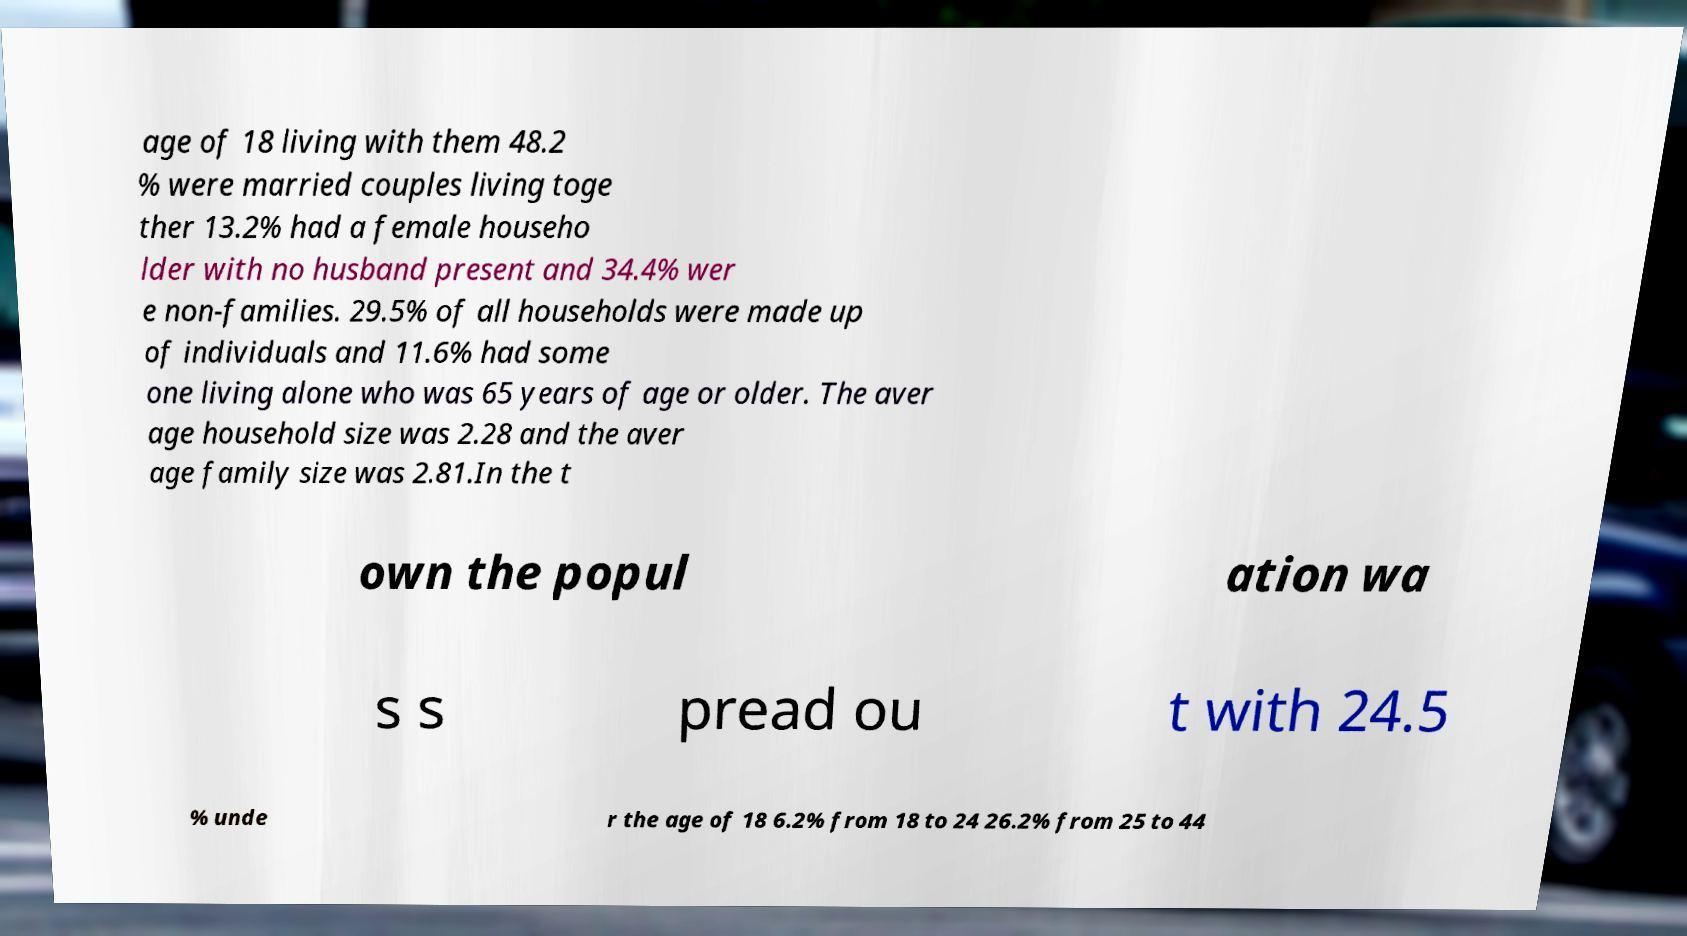For documentation purposes, I need the text within this image transcribed. Could you provide that? age of 18 living with them 48.2 % were married couples living toge ther 13.2% had a female househo lder with no husband present and 34.4% wer e non-families. 29.5% of all households were made up of individuals and 11.6% had some one living alone who was 65 years of age or older. The aver age household size was 2.28 and the aver age family size was 2.81.In the t own the popul ation wa s s pread ou t with 24.5 % unde r the age of 18 6.2% from 18 to 24 26.2% from 25 to 44 